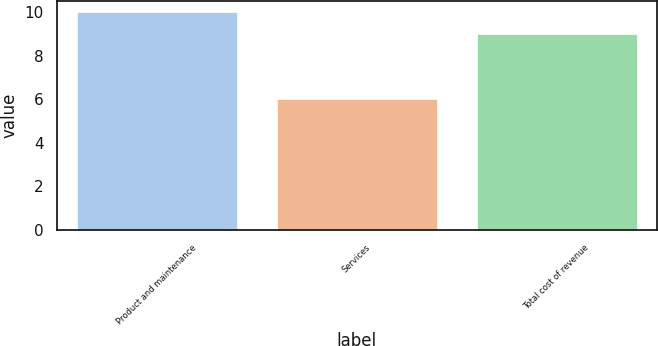Convert chart. <chart><loc_0><loc_0><loc_500><loc_500><bar_chart><fcel>Product and maintenance<fcel>Services<fcel>Total cost of revenue<nl><fcel>10<fcel>6<fcel>9<nl></chart> 